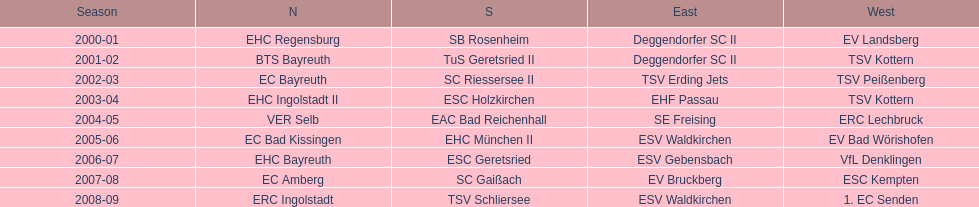What is the number of seasons covered in the table? 9. 